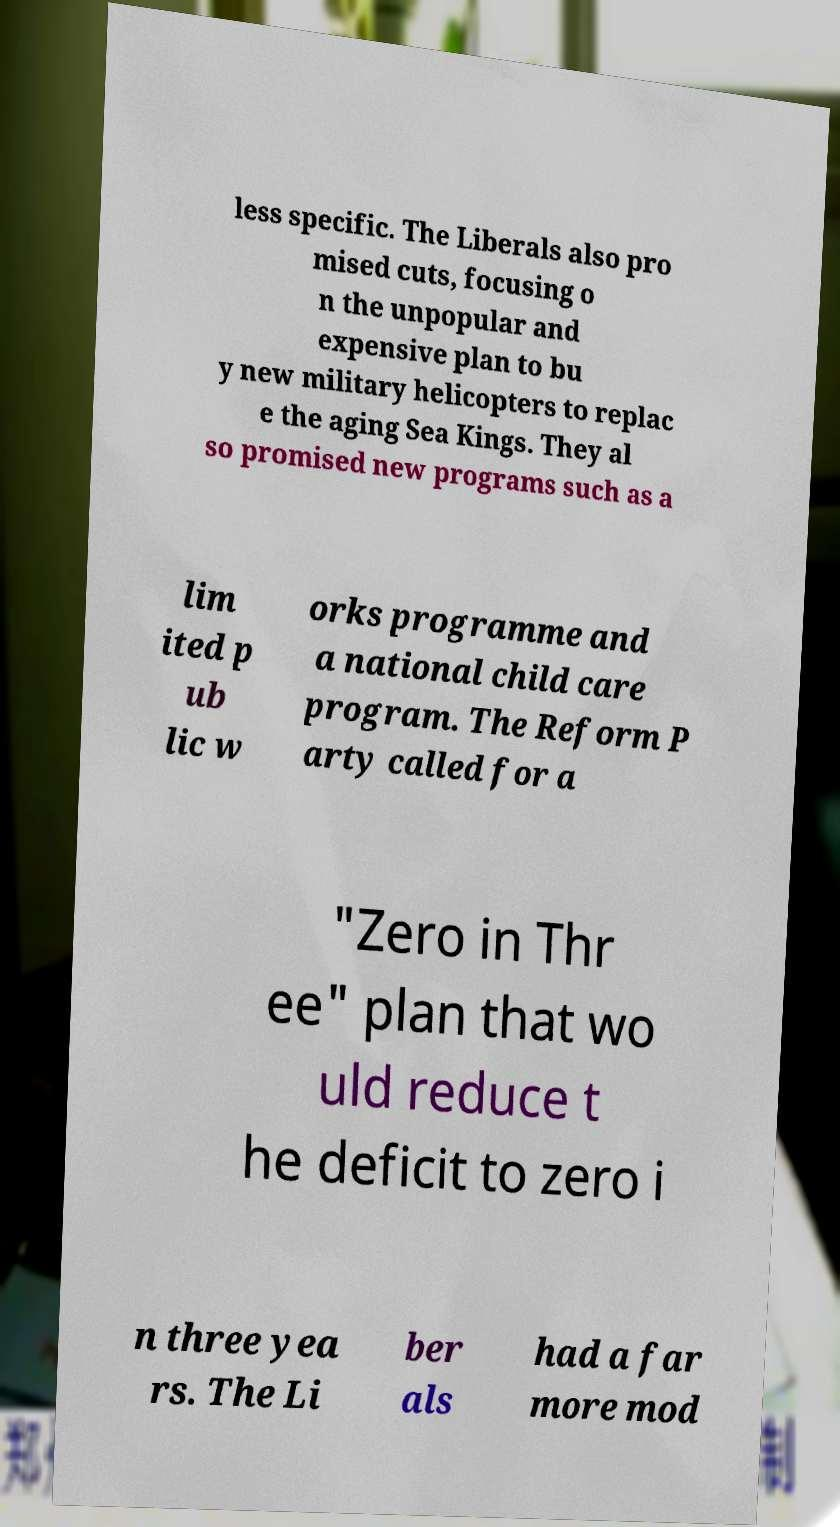Can you read and provide the text displayed in the image?This photo seems to have some interesting text. Can you extract and type it out for me? less specific. The Liberals also pro mised cuts, focusing o n the unpopular and expensive plan to bu y new military helicopters to replac e the aging Sea Kings. They al so promised new programs such as a lim ited p ub lic w orks programme and a national child care program. The Reform P arty called for a "Zero in Thr ee" plan that wo uld reduce t he deficit to zero i n three yea rs. The Li ber als had a far more mod 